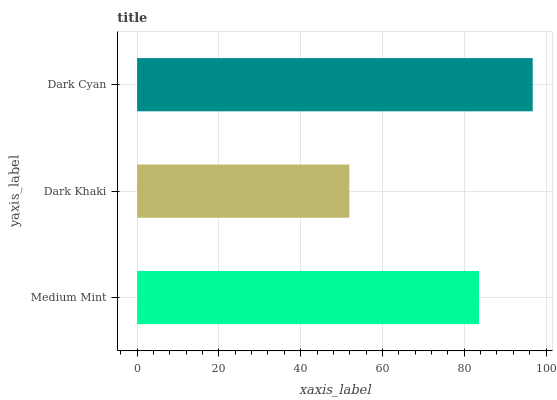Is Dark Khaki the minimum?
Answer yes or no. Yes. Is Dark Cyan the maximum?
Answer yes or no. Yes. Is Dark Cyan the minimum?
Answer yes or no. No. Is Dark Khaki the maximum?
Answer yes or no. No. Is Dark Cyan greater than Dark Khaki?
Answer yes or no. Yes. Is Dark Khaki less than Dark Cyan?
Answer yes or no. Yes. Is Dark Khaki greater than Dark Cyan?
Answer yes or no. No. Is Dark Cyan less than Dark Khaki?
Answer yes or no. No. Is Medium Mint the high median?
Answer yes or no. Yes. Is Medium Mint the low median?
Answer yes or no. Yes. Is Dark Khaki the high median?
Answer yes or no. No. Is Dark Khaki the low median?
Answer yes or no. No. 